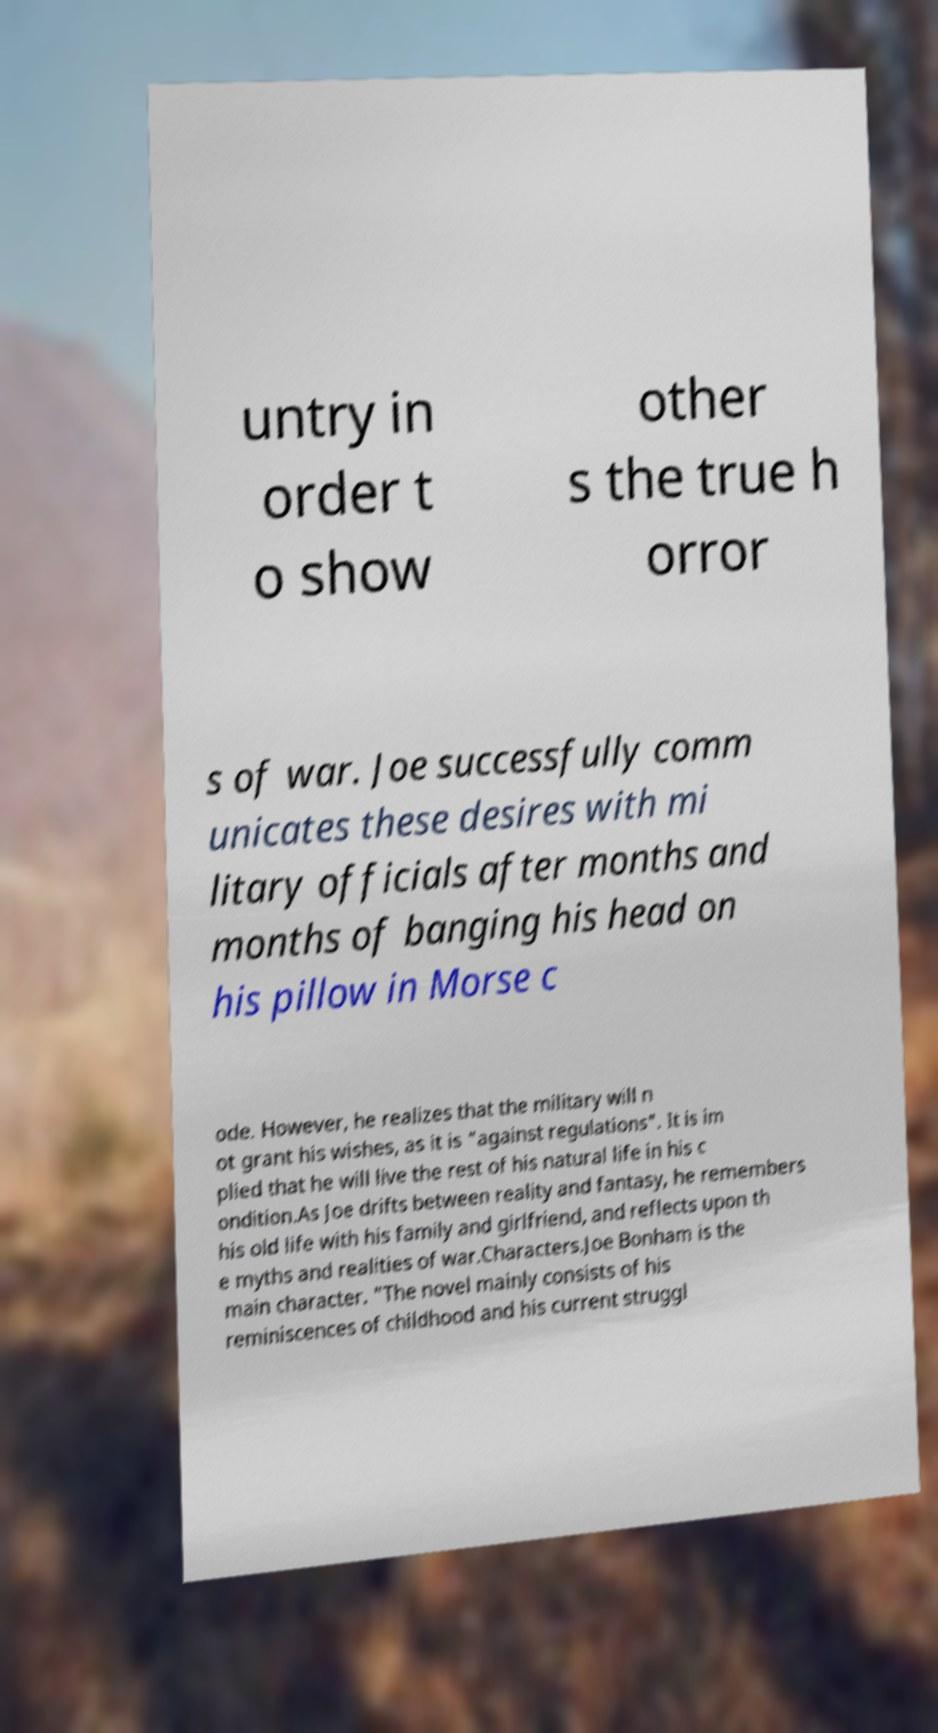Can you accurately transcribe the text from the provided image for me? untry in order t o show other s the true h orror s of war. Joe successfully comm unicates these desires with mi litary officials after months and months of banging his head on his pillow in Morse c ode. However, he realizes that the military will n ot grant his wishes, as it is "against regulations". It is im plied that he will live the rest of his natural life in his c ondition.As Joe drifts between reality and fantasy, he remembers his old life with his family and girlfriend, and reflects upon th e myths and realities of war.Characters.Joe Bonham is the main character. "The novel mainly consists of his reminiscences of childhood and his current struggl 